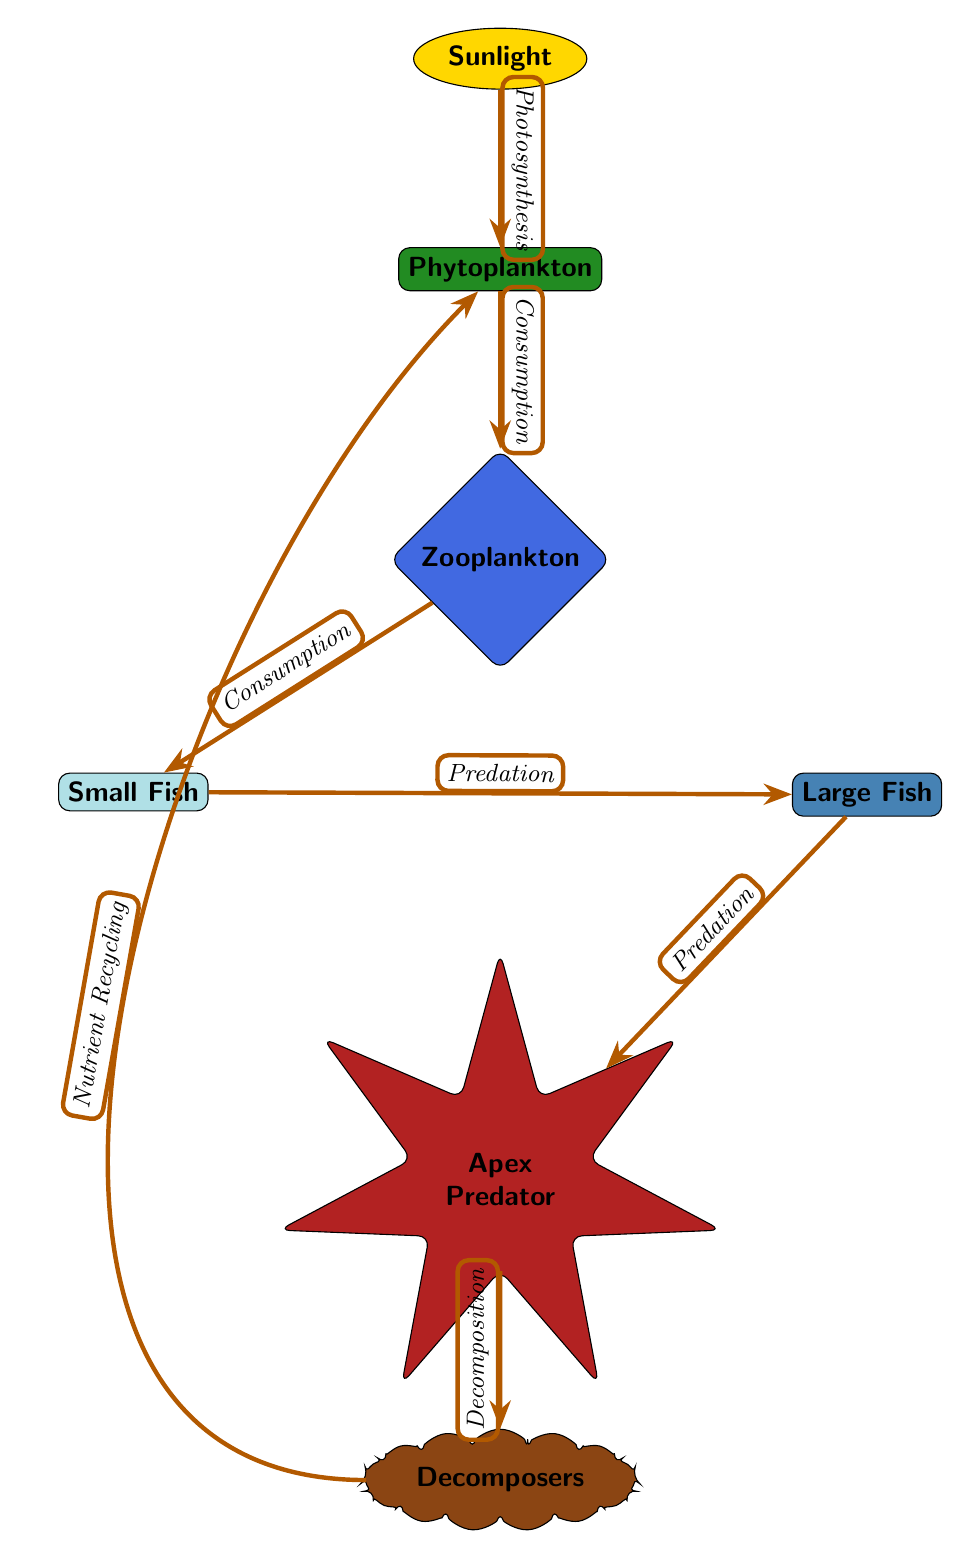What is the primary source of energy in this food chain? The diagram indicates that sunlight is the primary source of energy, as it is represented at the top and flows downwards through various trophic levels.
Answer: Sunlight How many trophic levels are represented in the diagram? The diagram shows five distinct trophic levels: 1) Phytoplankton, 2) Zooplankton, 3) Small Fish, 4) Large Fish, and 5) Apex Predator. The decomposers are also included, but they do not represent a trophic level in the consumer hierarchy.
Answer: Five What process transfers energy from phytoplankton to zooplankton? The diagram indicates that the energy transfer from phytoplankton to zooplankton occurs through the process of consumption, as labeled on the connecting arrow.
Answer: Consumption Which trophic level consumes small fish? According to the diagram, large fish consume small fish, evidenced by the arrow pointing from small fish to large fish labeled with predation.
Answer: Large Fish What happens to energy after it reaches the apex predator? The arrow shows that after energy reaches the apex predator, it is transferred to decomposers through the process of decomposition, which facilitates nutrient recycling and illustrates the closing of the nutrient cycle.
Answer: Decomposition Which organism is at the base of the food chain? The diagram clearly shows that phytoplankton is at the base of the food chain, as it is the first consumer level receiving energy from sunlight.
Answer: Phytoplankton How is nutrient recycling depicted in the food chain? The diagram illustrates nutrient recycling with an arrow that points from decomposers back to phytoplankton, suggesting that decomposers break down organic matter and return nutrients to the environment for uptake by producers.
Answer: Nutrient Recycling What type of relationship exists between zooplankton and phytoplankton? The relationship depicted in the diagram is a consumption relationship, where zooplankton feed on phytoplankton, as indicated by the corresponding arrow and its label.
Answer: Consumption What is the final organism in this food chain? The apex predator is identified as the final organism in this food chain, positioned at the bottom of the diagram indicating it is at the highest trophic level.
Answer: Apex Predator 